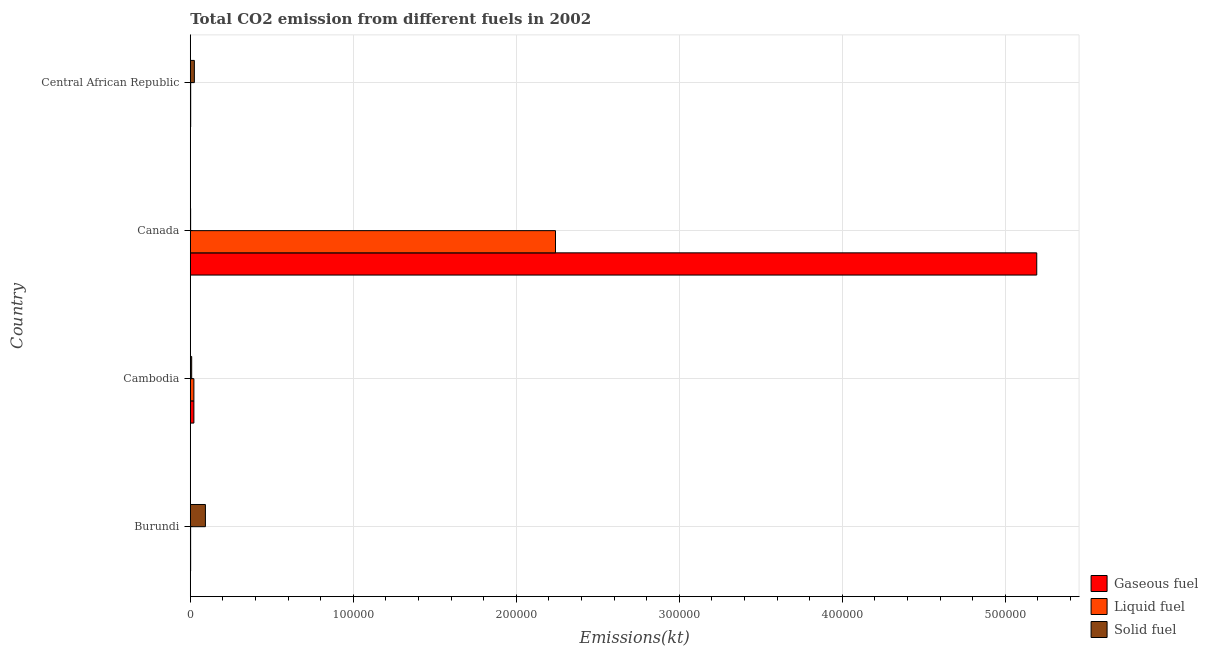How many different coloured bars are there?
Your response must be concise. 3. How many groups of bars are there?
Your answer should be compact. 4. Are the number of bars per tick equal to the number of legend labels?
Give a very brief answer. Yes. How many bars are there on the 4th tick from the top?
Offer a terse response. 3. What is the label of the 3rd group of bars from the top?
Keep it short and to the point. Cambodia. What is the amount of co2 emissions from gaseous fuel in Central African Republic?
Keep it short and to the point. 245.69. Across all countries, what is the maximum amount of co2 emissions from solid fuel?
Offer a terse response. 9273.84. Across all countries, what is the minimum amount of co2 emissions from liquid fuel?
Provide a succinct answer. 201.69. In which country was the amount of co2 emissions from solid fuel maximum?
Your answer should be compact. Burundi. In which country was the amount of co2 emissions from liquid fuel minimum?
Provide a short and direct response. Burundi. What is the total amount of co2 emissions from solid fuel in the graph?
Ensure brevity in your answer.  1.28e+04. What is the difference between the amount of co2 emissions from liquid fuel in Burundi and that in Canada?
Keep it short and to the point. -2.24e+05. What is the difference between the amount of co2 emissions from gaseous fuel in Burundi and the amount of co2 emissions from solid fuel in Central African Republic?
Provide a short and direct response. -2280.87. What is the average amount of co2 emissions from liquid fuel per country?
Make the answer very short. 5.67e+04. What is the difference between the amount of co2 emissions from solid fuel and amount of co2 emissions from liquid fuel in Burundi?
Make the answer very short. 9072.16. In how many countries, is the amount of co2 emissions from liquid fuel greater than 480000 kt?
Keep it short and to the point. 0. What is the ratio of the amount of co2 emissions from liquid fuel in Burundi to that in Central African Republic?
Offer a terse response. 0.82. What is the difference between the highest and the second highest amount of co2 emissions from gaseous fuel?
Offer a very short reply. 5.17e+05. What is the difference between the highest and the lowest amount of co2 emissions from gaseous fuel?
Your answer should be very brief. 5.19e+05. What does the 2nd bar from the top in Canada represents?
Provide a short and direct response. Liquid fuel. What does the 1st bar from the bottom in Central African Republic represents?
Ensure brevity in your answer.  Gaseous fuel. Is it the case that in every country, the sum of the amount of co2 emissions from gaseous fuel and amount of co2 emissions from liquid fuel is greater than the amount of co2 emissions from solid fuel?
Offer a very short reply. No. Are the values on the major ticks of X-axis written in scientific E-notation?
Give a very brief answer. No. Does the graph contain any zero values?
Give a very brief answer. No. Does the graph contain grids?
Offer a terse response. Yes. What is the title of the graph?
Give a very brief answer. Total CO2 emission from different fuels in 2002. Does "Male employers" appear as one of the legend labels in the graph?
Your answer should be very brief. No. What is the label or title of the X-axis?
Your answer should be compact. Emissions(kt). What is the Emissions(kt) of Gaseous fuel in Burundi?
Your answer should be compact. 212.69. What is the Emissions(kt) in Liquid fuel in Burundi?
Make the answer very short. 201.69. What is the Emissions(kt) of Solid fuel in Burundi?
Give a very brief answer. 9273.84. What is the Emissions(kt) of Gaseous fuel in Cambodia?
Offer a very short reply. 2207.53. What is the Emissions(kt) of Liquid fuel in Cambodia?
Your response must be concise. 2207.53. What is the Emissions(kt) in Solid fuel in Cambodia?
Your answer should be very brief. 854.41. What is the Emissions(kt) in Gaseous fuel in Canada?
Make the answer very short. 5.19e+05. What is the Emissions(kt) in Liquid fuel in Canada?
Keep it short and to the point. 2.24e+05. What is the Emissions(kt) in Solid fuel in Canada?
Your response must be concise. 201.69. What is the Emissions(kt) in Gaseous fuel in Central African Republic?
Your answer should be compact. 245.69. What is the Emissions(kt) in Liquid fuel in Central African Republic?
Your answer should be very brief. 245.69. What is the Emissions(kt) of Solid fuel in Central African Republic?
Give a very brief answer. 2493.56. Across all countries, what is the maximum Emissions(kt) of Gaseous fuel?
Your response must be concise. 5.19e+05. Across all countries, what is the maximum Emissions(kt) of Liquid fuel?
Ensure brevity in your answer.  2.24e+05. Across all countries, what is the maximum Emissions(kt) in Solid fuel?
Your answer should be very brief. 9273.84. Across all countries, what is the minimum Emissions(kt) in Gaseous fuel?
Your answer should be compact. 212.69. Across all countries, what is the minimum Emissions(kt) in Liquid fuel?
Your answer should be compact. 201.69. Across all countries, what is the minimum Emissions(kt) of Solid fuel?
Your response must be concise. 201.69. What is the total Emissions(kt) of Gaseous fuel in the graph?
Offer a very short reply. 5.22e+05. What is the total Emissions(kt) of Liquid fuel in the graph?
Provide a succinct answer. 2.27e+05. What is the total Emissions(kt) of Solid fuel in the graph?
Ensure brevity in your answer.  1.28e+04. What is the difference between the Emissions(kt) of Gaseous fuel in Burundi and that in Cambodia?
Keep it short and to the point. -1994.85. What is the difference between the Emissions(kt) of Liquid fuel in Burundi and that in Cambodia?
Offer a terse response. -2005.85. What is the difference between the Emissions(kt) in Solid fuel in Burundi and that in Cambodia?
Give a very brief answer. 8419.43. What is the difference between the Emissions(kt) of Gaseous fuel in Burundi and that in Canada?
Provide a short and direct response. -5.19e+05. What is the difference between the Emissions(kt) of Liquid fuel in Burundi and that in Canada?
Your answer should be compact. -2.24e+05. What is the difference between the Emissions(kt) of Solid fuel in Burundi and that in Canada?
Make the answer very short. 9072.16. What is the difference between the Emissions(kt) in Gaseous fuel in Burundi and that in Central African Republic?
Keep it short and to the point. -33. What is the difference between the Emissions(kt) of Liquid fuel in Burundi and that in Central African Republic?
Your answer should be very brief. -44. What is the difference between the Emissions(kt) in Solid fuel in Burundi and that in Central African Republic?
Offer a very short reply. 6780.28. What is the difference between the Emissions(kt) in Gaseous fuel in Cambodia and that in Canada?
Provide a succinct answer. -5.17e+05. What is the difference between the Emissions(kt) in Liquid fuel in Cambodia and that in Canada?
Your answer should be compact. -2.22e+05. What is the difference between the Emissions(kt) in Solid fuel in Cambodia and that in Canada?
Provide a short and direct response. 652.73. What is the difference between the Emissions(kt) in Gaseous fuel in Cambodia and that in Central African Republic?
Ensure brevity in your answer.  1961.85. What is the difference between the Emissions(kt) of Liquid fuel in Cambodia and that in Central African Republic?
Ensure brevity in your answer.  1961.85. What is the difference between the Emissions(kt) of Solid fuel in Cambodia and that in Central African Republic?
Your answer should be compact. -1639.15. What is the difference between the Emissions(kt) of Gaseous fuel in Canada and that in Central African Republic?
Provide a short and direct response. 5.19e+05. What is the difference between the Emissions(kt) of Liquid fuel in Canada and that in Central African Republic?
Provide a short and direct response. 2.24e+05. What is the difference between the Emissions(kt) in Solid fuel in Canada and that in Central African Republic?
Your answer should be very brief. -2291.88. What is the difference between the Emissions(kt) of Gaseous fuel in Burundi and the Emissions(kt) of Liquid fuel in Cambodia?
Your answer should be compact. -1994.85. What is the difference between the Emissions(kt) of Gaseous fuel in Burundi and the Emissions(kt) of Solid fuel in Cambodia?
Ensure brevity in your answer.  -641.73. What is the difference between the Emissions(kt) of Liquid fuel in Burundi and the Emissions(kt) of Solid fuel in Cambodia?
Offer a very short reply. -652.73. What is the difference between the Emissions(kt) of Gaseous fuel in Burundi and the Emissions(kt) of Liquid fuel in Canada?
Offer a terse response. -2.24e+05. What is the difference between the Emissions(kt) in Gaseous fuel in Burundi and the Emissions(kt) in Solid fuel in Canada?
Make the answer very short. 11. What is the difference between the Emissions(kt) in Liquid fuel in Burundi and the Emissions(kt) in Solid fuel in Canada?
Provide a succinct answer. 0. What is the difference between the Emissions(kt) in Gaseous fuel in Burundi and the Emissions(kt) in Liquid fuel in Central African Republic?
Offer a terse response. -33. What is the difference between the Emissions(kt) of Gaseous fuel in Burundi and the Emissions(kt) of Solid fuel in Central African Republic?
Give a very brief answer. -2280.87. What is the difference between the Emissions(kt) of Liquid fuel in Burundi and the Emissions(kt) of Solid fuel in Central African Republic?
Provide a short and direct response. -2291.88. What is the difference between the Emissions(kt) in Gaseous fuel in Cambodia and the Emissions(kt) in Liquid fuel in Canada?
Your answer should be very brief. -2.22e+05. What is the difference between the Emissions(kt) in Gaseous fuel in Cambodia and the Emissions(kt) in Solid fuel in Canada?
Provide a short and direct response. 2005.85. What is the difference between the Emissions(kt) of Liquid fuel in Cambodia and the Emissions(kt) of Solid fuel in Canada?
Your answer should be compact. 2005.85. What is the difference between the Emissions(kt) in Gaseous fuel in Cambodia and the Emissions(kt) in Liquid fuel in Central African Republic?
Offer a very short reply. 1961.85. What is the difference between the Emissions(kt) in Gaseous fuel in Cambodia and the Emissions(kt) in Solid fuel in Central African Republic?
Your answer should be very brief. -286.03. What is the difference between the Emissions(kt) in Liquid fuel in Cambodia and the Emissions(kt) in Solid fuel in Central African Republic?
Your answer should be compact. -286.03. What is the difference between the Emissions(kt) in Gaseous fuel in Canada and the Emissions(kt) in Liquid fuel in Central African Republic?
Make the answer very short. 5.19e+05. What is the difference between the Emissions(kt) of Gaseous fuel in Canada and the Emissions(kt) of Solid fuel in Central African Republic?
Offer a very short reply. 5.17e+05. What is the difference between the Emissions(kt) in Liquid fuel in Canada and the Emissions(kt) in Solid fuel in Central African Republic?
Your response must be concise. 2.22e+05. What is the average Emissions(kt) of Gaseous fuel per country?
Keep it short and to the point. 1.31e+05. What is the average Emissions(kt) in Liquid fuel per country?
Provide a succinct answer. 5.67e+04. What is the average Emissions(kt) of Solid fuel per country?
Make the answer very short. 3205.87. What is the difference between the Emissions(kt) in Gaseous fuel and Emissions(kt) in Liquid fuel in Burundi?
Provide a short and direct response. 11. What is the difference between the Emissions(kt) in Gaseous fuel and Emissions(kt) in Solid fuel in Burundi?
Provide a short and direct response. -9061.16. What is the difference between the Emissions(kt) of Liquid fuel and Emissions(kt) of Solid fuel in Burundi?
Give a very brief answer. -9072.16. What is the difference between the Emissions(kt) in Gaseous fuel and Emissions(kt) in Solid fuel in Cambodia?
Keep it short and to the point. 1353.12. What is the difference between the Emissions(kt) in Liquid fuel and Emissions(kt) in Solid fuel in Cambodia?
Give a very brief answer. 1353.12. What is the difference between the Emissions(kt) of Gaseous fuel and Emissions(kt) of Liquid fuel in Canada?
Offer a terse response. 2.95e+05. What is the difference between the Emissions(kt) in Gaseous fuel and Emissions(kt) in Solid fuel in Canada?
Offer a very short reply. 5.19e+05. What is the difference between the Emissions(kt) of Liquid fuel and Emissions(kt) of Solid fuel in Canada?
Make the answer very short. 2.24e+05. What is the difference between the Emissions(kt) of Gaseous fuel and Emissions(kt) of Liquid fuel in Central African Republic?
Your response must be concise. 0. What is the difference between the Emissions(kt) in Gaseous fuel and Emissions(kt) in Solid fuel in Central African Republic?
Your answer should be very brief. -2247.87. What is the difference between the Emissions(kt) in Liquid fuel and Emissions(kt) in Solid fuel in Central African Republic?
Provide a succinct answer. -2247.87. What is the ratio of the Emissions(kt) in Gaseous fuel in Burundi to that in Cambodia?
Provide a succinct answer. 0.1. What is the ratio of the Emissions(kt) in Liquid fuel in Burundi to that in Cambodia?
Your answer should be compact. 0.09. What is the ratio of the Emissions(kt) of Solid fuel in Burundi to that in Cambodia?
Your response must be concise. 10.85. What is the ratio of the Emissions(kt) in Gaseous fuel in Burundi to that in Canada?
Provide a short and direct response. 0. What is the ratio of the Emissions(kt) in Liquid fuel in Burundi to that in Canada?
Keep it short and to the point. 0. What is the ratio of the Emissions(kt) of Solid fuel in Burundi to that in Canada?
Make the answer very short. 45.98. What is the ratio of the Emissions(kt) in Gaseous fuel in Burundi to that in Central African Republic?
Make the answer very short. 0.87. What is the ratio of the Emissions(kt) of Liquid fuel in Burundi to that in Central African Republic?
Provide a succinct answer. 0.82. What is the ratio of the Emissions(kt) in Solid fuel in Burundi to that in Central African Republic?
Ensure brevity in your answer.  3.72. What is the ratio of the Emissions(kt) in Gaseous fuel in Cambodia to that in Canada?
Offer a terse response. 0. What is the ratio of the Emissions(kt) in Liquid fuel in Cambodia to that in Canada?
Provide a short and direct response. 0.01. What is the ratio of the Emissions(kt) of Solid fuel in Cambodia to that in Canada?
Your answer should be compact. 4.24. What is the ratio of the Emissions(kt) in Gaseous fuel in Cambodia to that in Central African Republic?
Provide a short and direct response. 8.99. What is the ratio of the Emissions(kt) of Liquid fuel in Cambodia to that in Central African Republic?
Keep it short and to the point. 8.99. What is the ratio of the Emissions(kt) in Solid fuel in Cambodia to that in Central African Republic?
Keep it short and to the point. 0.34. What is the ratio of the Emissions(kt) of Gaseous fuel in Canada to that in Central African Republic?
Ensure brevity in your answer.  2113.79. What is the ratio of the Emissions(kt) of Liquid fuel in Canada to that in Central African Republic?
Give a very brief answer. 911.99. What is the ratio of the Emissions(kt) of Solid fuel in Canada to that in Central African Republic?
Your answer should be compact. 0.08. What is the difference between the highest and the second highest Emissions(kt) of Gaseous fuel?
Ensure brevity in your answer.  5.17e+05. What is the difference between the highest and the second highest Emissions(kt) of Liquid fuel?
Make the answer very short. 2.22e+05. What is the difference between the highest and the second highest Emissions(kt) of Solid fuel?
Provide a short and direct response. 6780.28. What is the difference between the highest and the lowest Emissions(kt) in Gaseous fuel?
Your response must be concise. 5.19e+05. What is the difference between the highest and the lowest Emissions(kt) of Liquid fuel?
Make the answer very short. 2.24e+05. What is the difference between the highest and the lowest Emissions(kt) in Solid fuel?
Keep it short and to the point. 9072.16. 